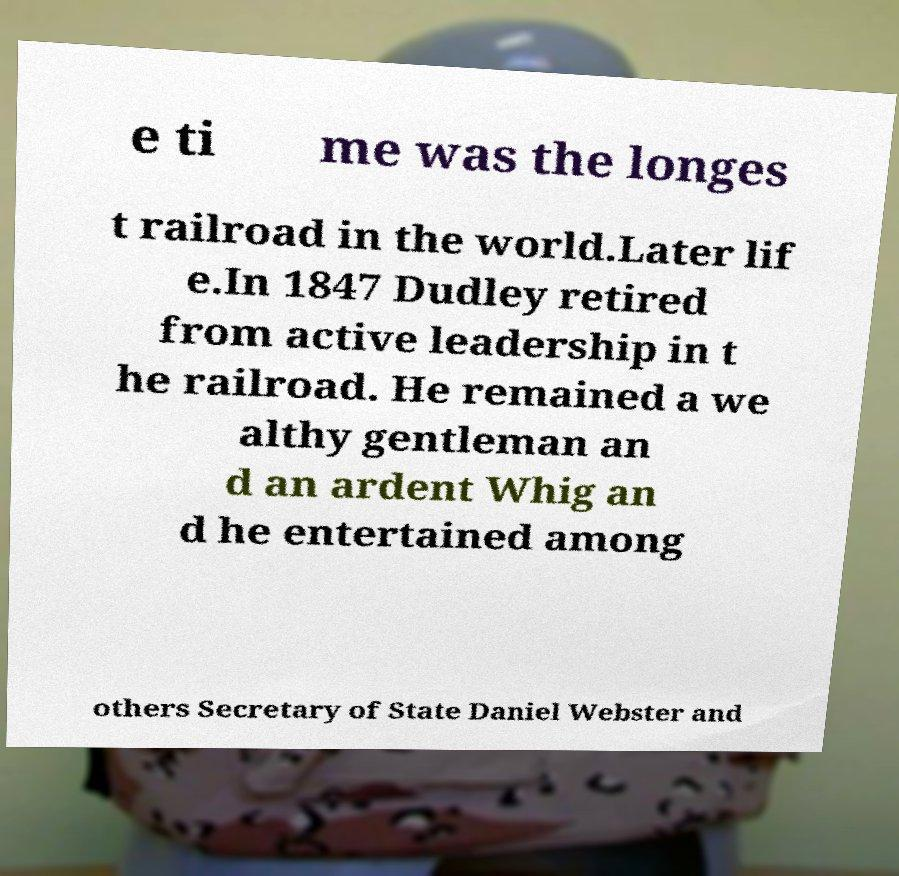Please read and relay the text visible in this image. What does it say? e ti me was the longes t railroad in the world.Later lif e.In 1847 Dudley retired from active leadership in t he railroad. He remained a we althy gentleman an d an ardent Whig an d he entertained among others Secretary of State Daniel Webster and 